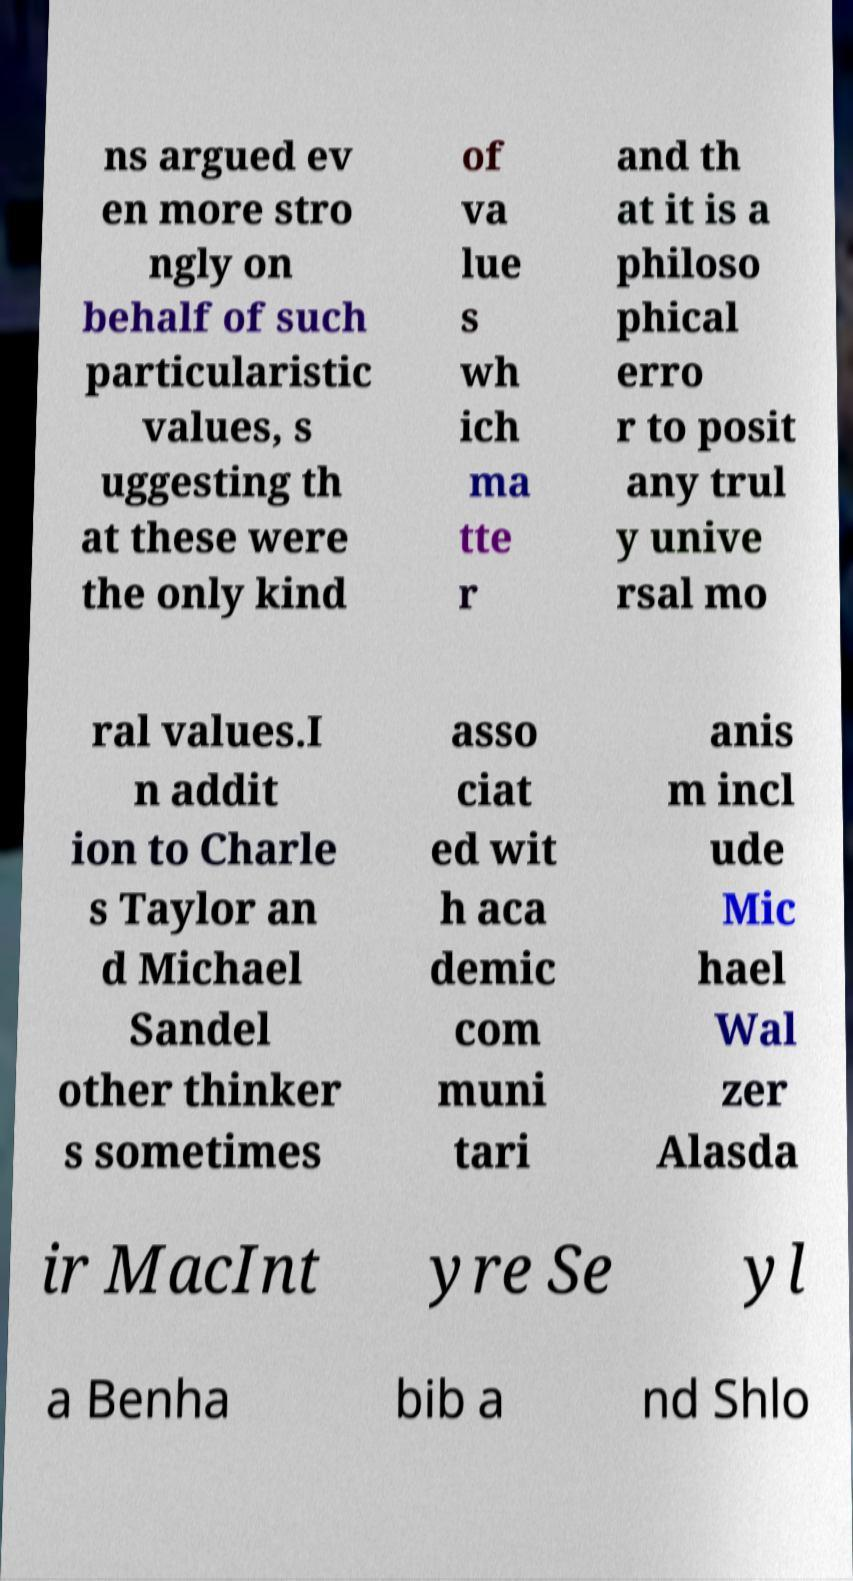For documentation purposes, I need the text within this image transcribed. Could you provide that? ns argued ev en more stro ngly on behalf of such particularistic values, s uggesting th at these were the only kind of va lue s wh ich ma tte r and th at it is a philoso phical erro r to posit any trul y unive rsal mo ral values.I n addit ion to Charle s Taylor an d Michael Sandel other thinker s sometimes asso ciat ed wit h aca demic com muni tari anis m incl ude Mic hael Wal zer Alasda ir MacInt yre Se yl a Benha bib a nd Shlo 